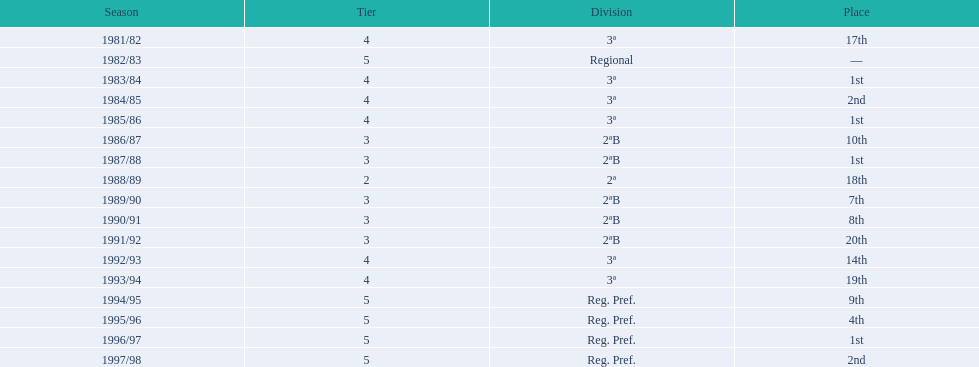What is the count of instances where second place was secured? 2. 